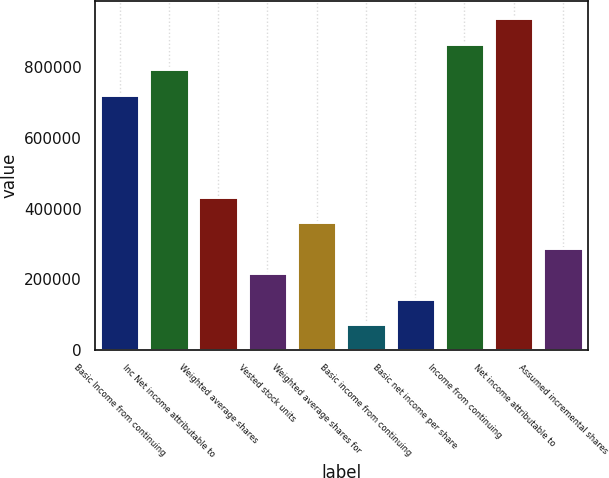Convert chart to OTSL. <chart><loc_0><loc_0><loc_500><loc_500><bar_chart><fcel>Basic Income from continuing<fcel>Inc Net income attributable to<fcel>Weighted average shares<fcel>Vested stock units<fcel>Weighted average shares for<fcel>Basic income from continuing<fcel>Basic net income per share<fcel>Income from continuing<fcel>Net income attributable to<fcel>Assumed incremental shares<nl><fcel>723114<fcel>795425<fcel>433870<fcel>216937<fcel>361559<fcel>72314.4<fcel>144625<fcel>867736<fcel>940047<fcel>289248<nl></chart> 